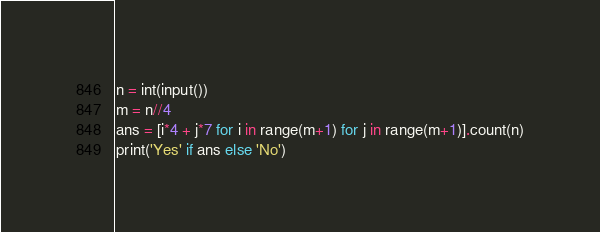Convert code to text. <code><loc_0><loc_0><loc_500><loc_500><_Python_>n = int(input())
m = n//4
ans = [i*4 + j*7 for i in range(m+1) for j in range(m+1)].count(n)
print('Yes' if ans else 'No')</code> 